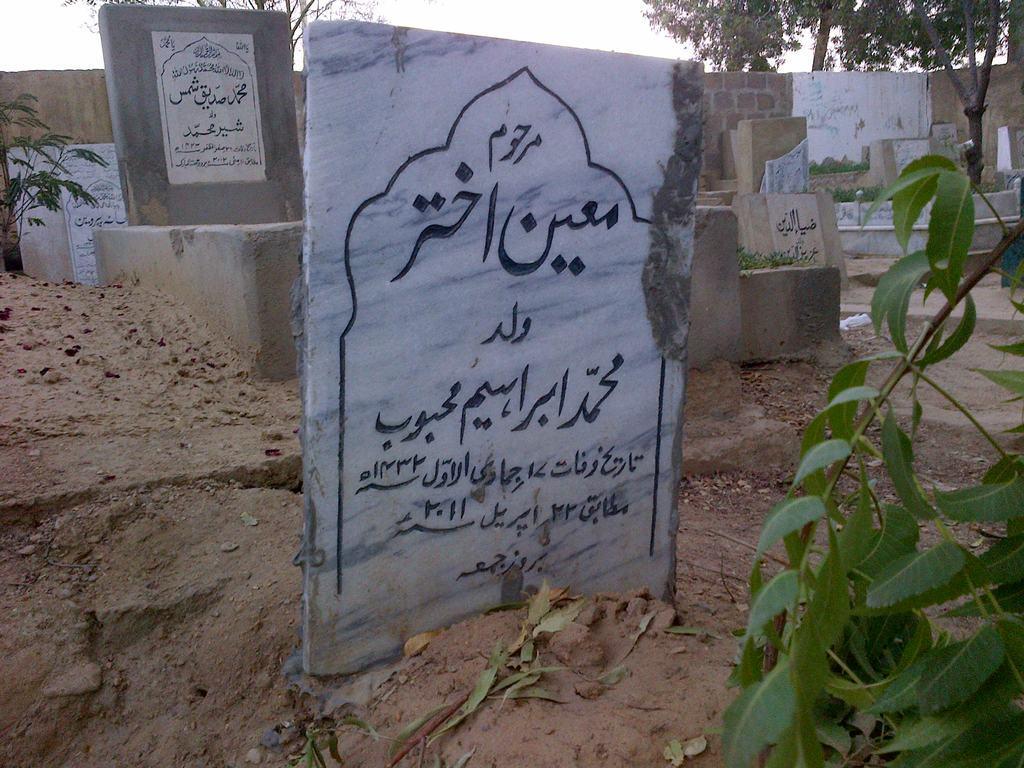Describe this image in one or two sentences. Here we can see stone boards, plants, and wall. In the background there are trees and sky. 